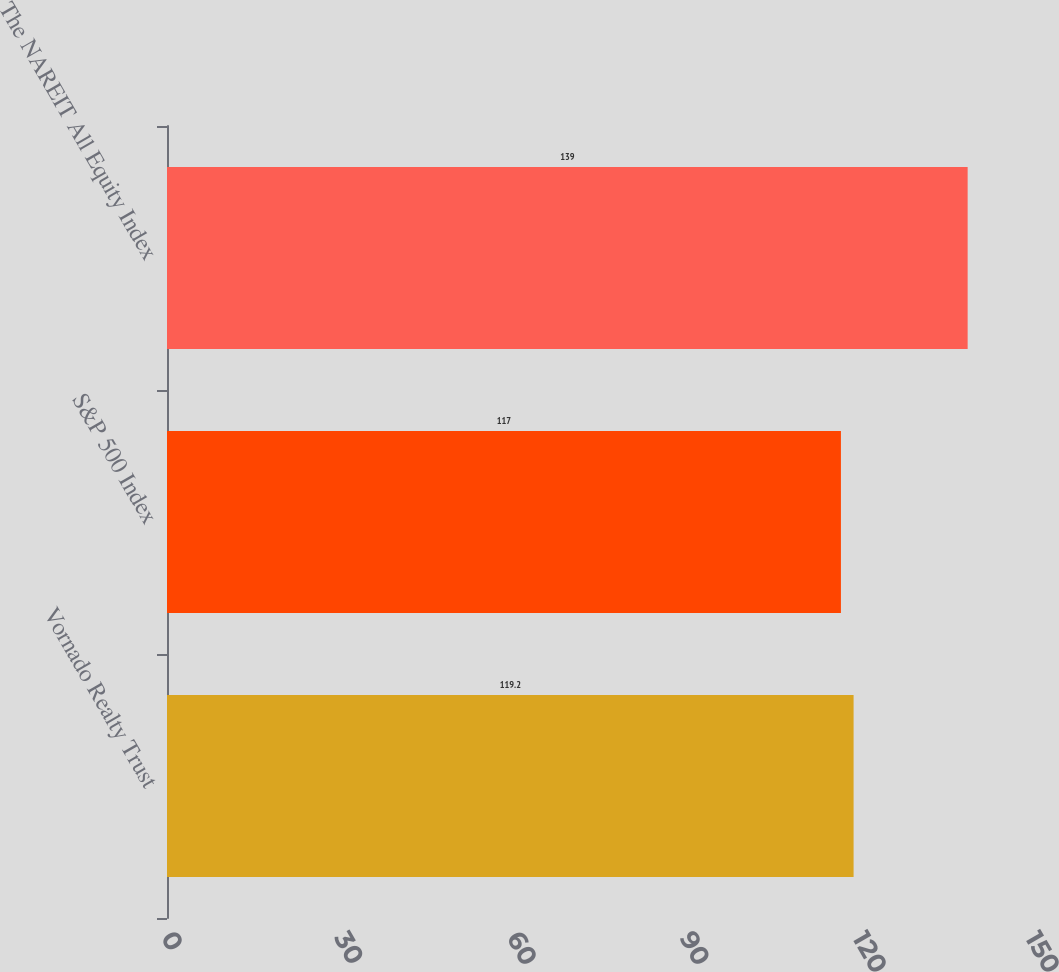Convert chart. <chart><loc_0><loc_0><loc_500><loc_500><bar_chart><fcel>Vornado Realty Trust<fcel>S&P 500 Index<fcel>The NAREIT All Equity Index<nl><fcel>119.2<fcel>117<fcel>139<nl></chart> 